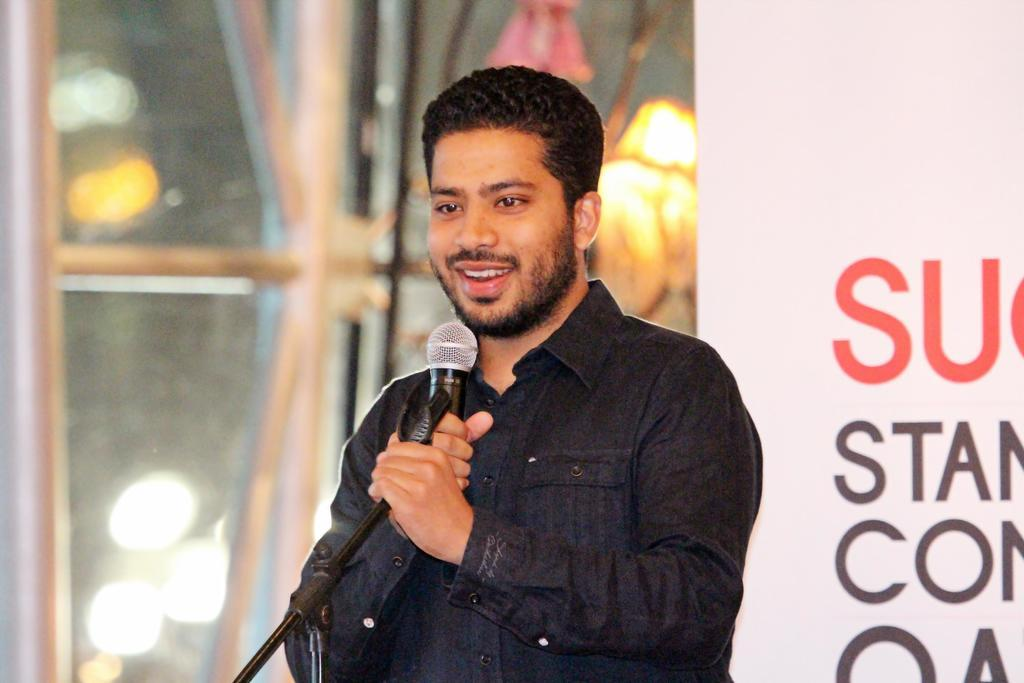Who or what is the main subject of the image? There is a person in the image. Can you describe the person's position in the image? The person is standing in the center of the image. What is the person holding in his hand? The person is holding a microphone in his hand. What is the person's facial expression in the image? The person is smiling. What type of juice is being squeezed out of the coal in the image? There is no juice or coal present in the image. What is the person's attraction in the image? There is no mention of an attraction in the image. The image only shows a person standing in the center, holding a microphone, and smiling. 